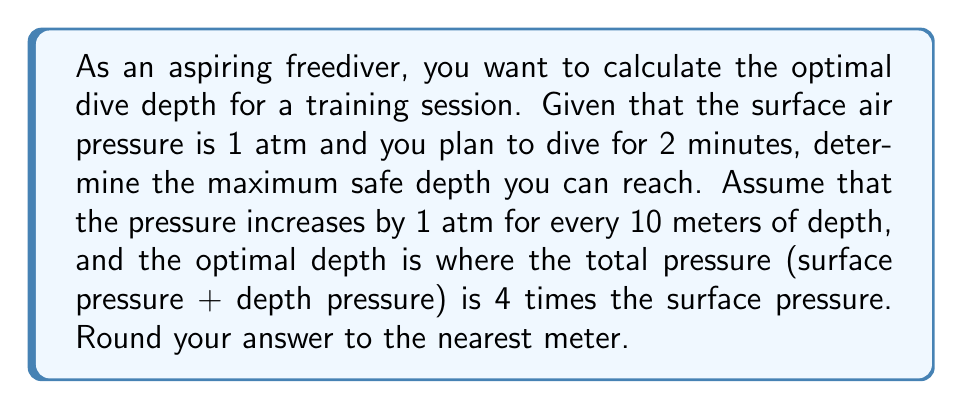What is the answer to this math problem? Let's approach this step-by-step:

1) First, we need to set up an equation for the total pressure at depth:

   $P_{total} = P_{surface} + P_{depth}$

2) We know that $P_{surface} = 1$ atm, and $P_{depth}$ increases by 1 atm for every 10 meters. So we can express $P_{depth}$ in terms of depth $d$ (in meters):

   $P_{depth} = \frac{d}{10}$ atm

3) Now our total pressure equation becomes:

   $P_{total} = 1 + \frac{d}{10}$

4) We're told that the optimal depth is where the total pressure is 4 times the surface pressure. We can express this as:

   $P_{total} = 4P_{surface}$

5) Substituting our expressions:

   $1 + \frac{d}{10} = 4(1)$

6) Simplify the right side:

   $1 + \frac{d}{10} = 4$

7) Subtract 1 from both sides:

   $\frac{d}{10} = 3$

8) Multiply both sides by 10:

   $d = 30$

9) Therefore, the optimal depth is 30 meters.
Answer: 30 meters 